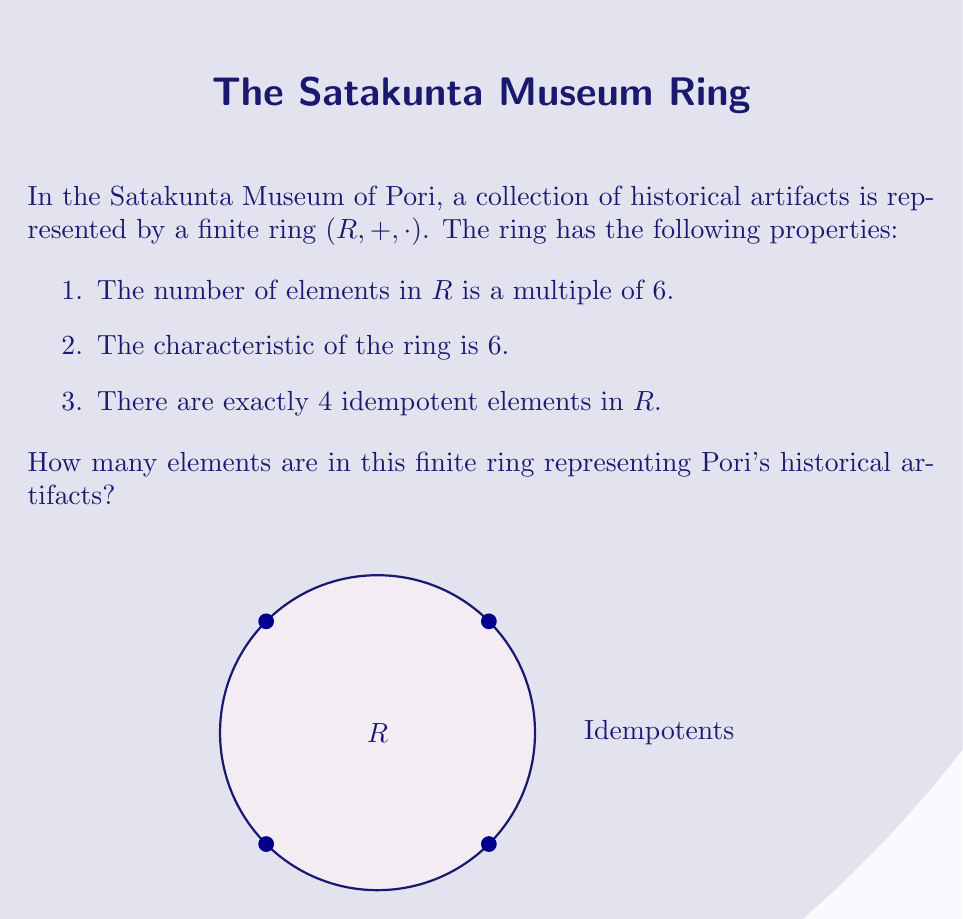What is the answer to this math problem? Let's approach this step-by-step:

1) The characteristic of a ring is the smallest positive integer $n$ such that $n \cdot 1 = 0$ for all elements in the ring. Here, $char(R) = 6$.

2) In a finite ring of characteristic 6, the number of elements must be a power of 6. This is because $6^k \cdot 1 = 0$ for some $k$.

3) Given that the number of elements is a multiple of 6, the possible sizes for $R$ are $6^1 = 6$, $6^2 = 36$, $6^3 = 216$, and so on.

4) Now, let's consider the idempotent elements. An element $e$ is idempotent if $e^2 = e$.

5) In any ring, 0 and 1 are always idempotent. So, we need to find a ring with exactly 2 additional idempotents.

6) The ring $\mathbb{Z}_6$ (integers modulo 6) has exactly 4 idempotents: 0, 1, 3, and 4.
   This is because:
   $0^2 \equiv 0 \pmod{6}$
   $1^2 \equiv 1 \pmod{6}$
   $3^2 \equiv 3 \pmod{6}$
   $4^2 \equiv 4 \pmod{6}$

7) Therefore, the ring $R$ must be isomorphic to $\mathbb{Z}_6$.

Thus, the finite ring representing Pori's historical artifacts has 6 elements.
Answer: 6 